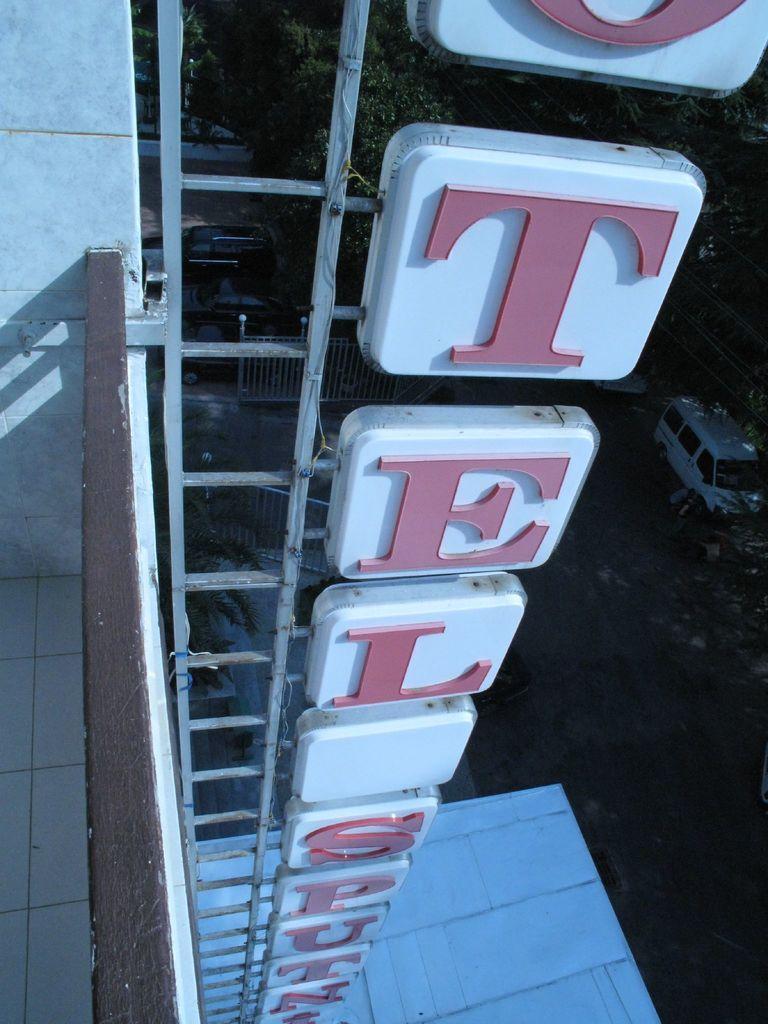In one or two sentences, can you explain what this image depicts? In this picture there is a naming board board with frame is placed on the building. In the bottom we can see white color van parked on the ground and some trees in the background. 